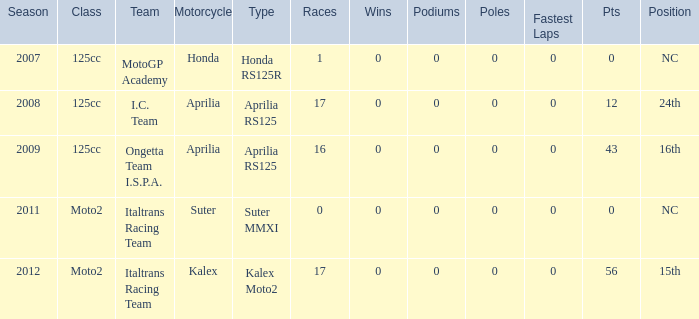Parse the table in full. {'header': ['Season', 'Class', 'Team', 'Motorcycle', 'Type', 'Races', 'Wins', 'Podiums', 'Poles', 'Fastest Laps', 'Pts', 'Position'], 'rows': [['2007', '125cc', 'MotoGP Academy', 'Honda', 'Honda RS125R', '1', '0', '0', '0', '0', '0', 'NC'], ['2008', '125cc', 'I.C. Team', 'Aprilia', 'Aprilia RS125', '17', '0', '0', '0', '0', '12', '24th'], ['2009', '125cc', 'Ongetta Team I.S.P.A.', 'Aprilia', 'Aprilia RS125', '16', '0', '0', '0', '0', '43', '16th'], ['2011', 'Moto2', 'Italtrans Racing Team', 'Suter', 'Suter MMXI', '0', '0', '0', '0', '0', '0', 'NC'], ['2012', 'Moto2', 'Italtrans Racing Team', 'Kalex', 'Kalex Moto2', '17', '0', '0', '0', '0', '56', '15th']]} What's the title of the group that possessed a honda motorcycle? MotoGP Academy. 